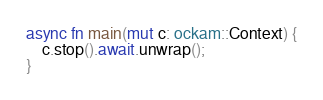Convert code to text. <code><loc_0><loc_0><loc_500><loc_500><_Rust_>async fn main(mut c: ockam::Context) {
    c.stop().await.unwrap();
}
</code> 